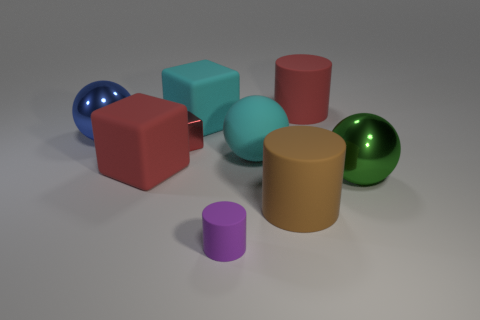Is there a large red cube made of the same material as the large blue thing?
Your answer should be compact. No. How many big things are in front of the large cyan matte sphere and on the right side of the tiny purple matte thing?
Your response must be concise. 2. Are there fewer rubber balls that are on the right side of the blue shiny sphere than large objects behind the big brown thing?
Your answer should be compact. Yes. Does the purple matte thing have the same shape as the brown thing?
Offer a terse response. Yes. How many other things are the same size as the blue shiny thing?
Ensure brevity in your answer.  6. How many things are objects that are in front of the red metallic thing or red objects on the right side of the purple thing?
Offer a very short reply. 6. What number of blue objects are the same shape as the green thing?
Ensure brevity in your answer.  1. There is a big sphere that is both in front of the tiny red metallic object and left of the brown cylinder; what material is it?
Make the answer very short. Rubber. What number of tiny objects are behind the green shiny thing?
Ensure brevity in your answer.  1. How many cyan balls are there?
Provide a short and direct response. 1. 